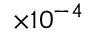<formula> <loc_0><loc_0><loc_500><loc_500>\times 1 0 ^ { - 4 }</formula> 